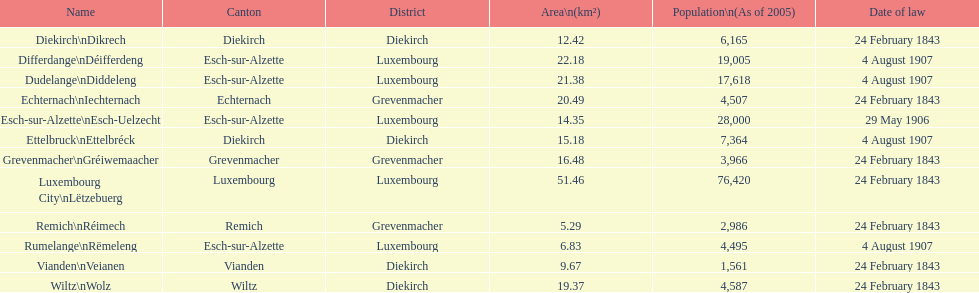Which canton is governed by the law of february 24, 1843, and has a population of 3,966? Grevenmacher. 